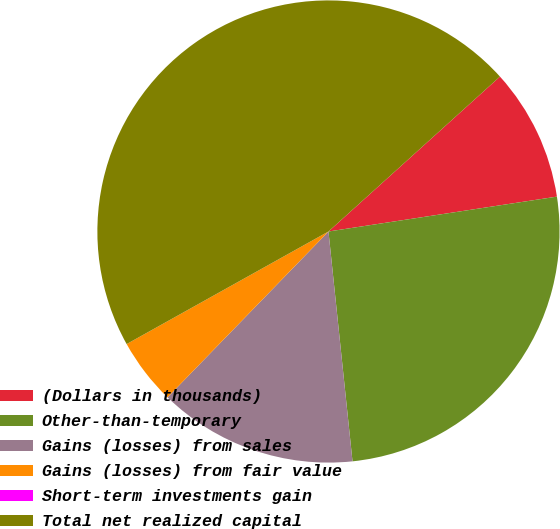Convert chart to OTSL. <chart><loc_0><loc_0><loc_500><loc_500><pie_chart><fcel>(Dollars in thousands)<fcel>Other-than-temporary<fcel>Gains (losses) from sales<fcel>Gains (losses) from fair value<fcel>Short-term investments gain<fcel>Total net realized capital<nl><fcel>9.28%<fcel>25.75%<fcel>13.92%<fcel>4.64%<fcel>0.0%<fcel>46.4%<nl></chart> 